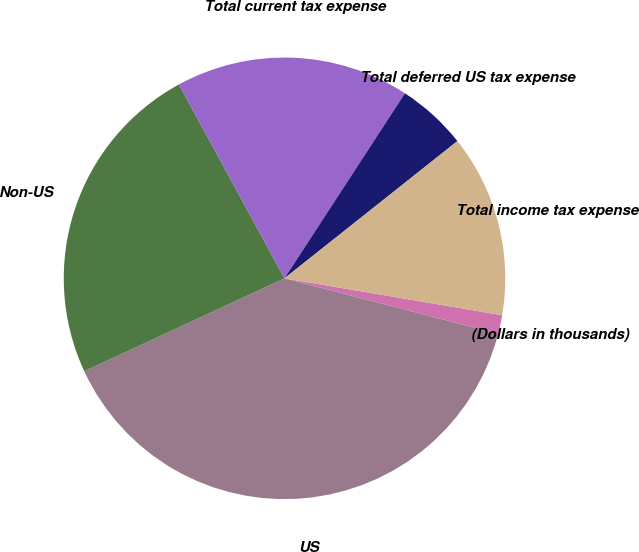<chart> <loc_0><loc_0><loc_500><loc_500><pie_chart><fcel>(Dollars in thousands)<fcel>US<fcel>Non-US<fcel>Total current tax expense<fcel>Total deferred US tax expense<fcel>Total income tax expense<nl><fcel>1.37%<fcel>39.04%<fcel>23.98%<fcel>17.12%<fcel>5.14%<fcel>13.35%<nl></chart> 